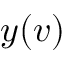Convert formula to latex. <formula><loc_0><loc_0><loc_500><loc_500>y ( v )</formula> 